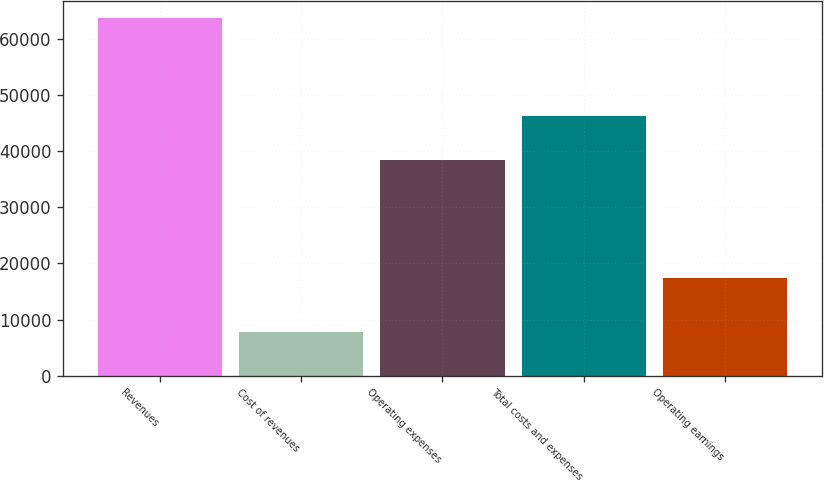<chart> <loc_0><loc_0><loc_500><loc_500><bar_chart><fcel>Revenues<fcel>Cost of revenues<fcel>Operating expenses<fcel>Total costs and expenses<fcel>Operating earnings<nl><fcel>63622<fcel>7809<fcel>38411<fcel>46220<fcel>17402<nl></chart> 